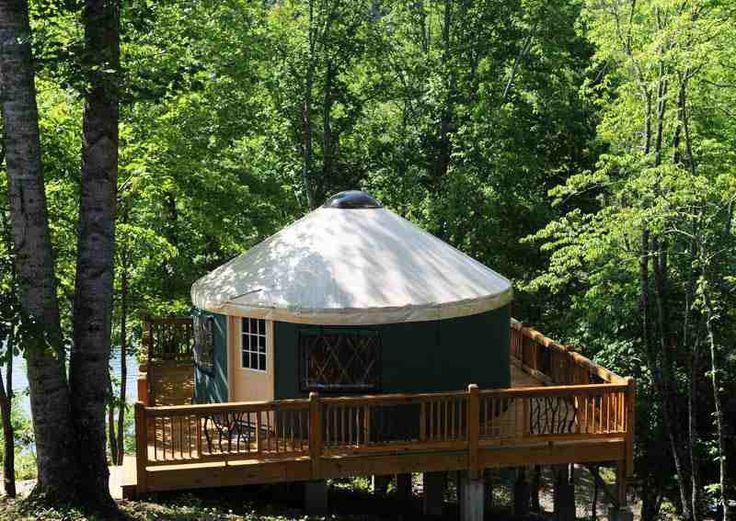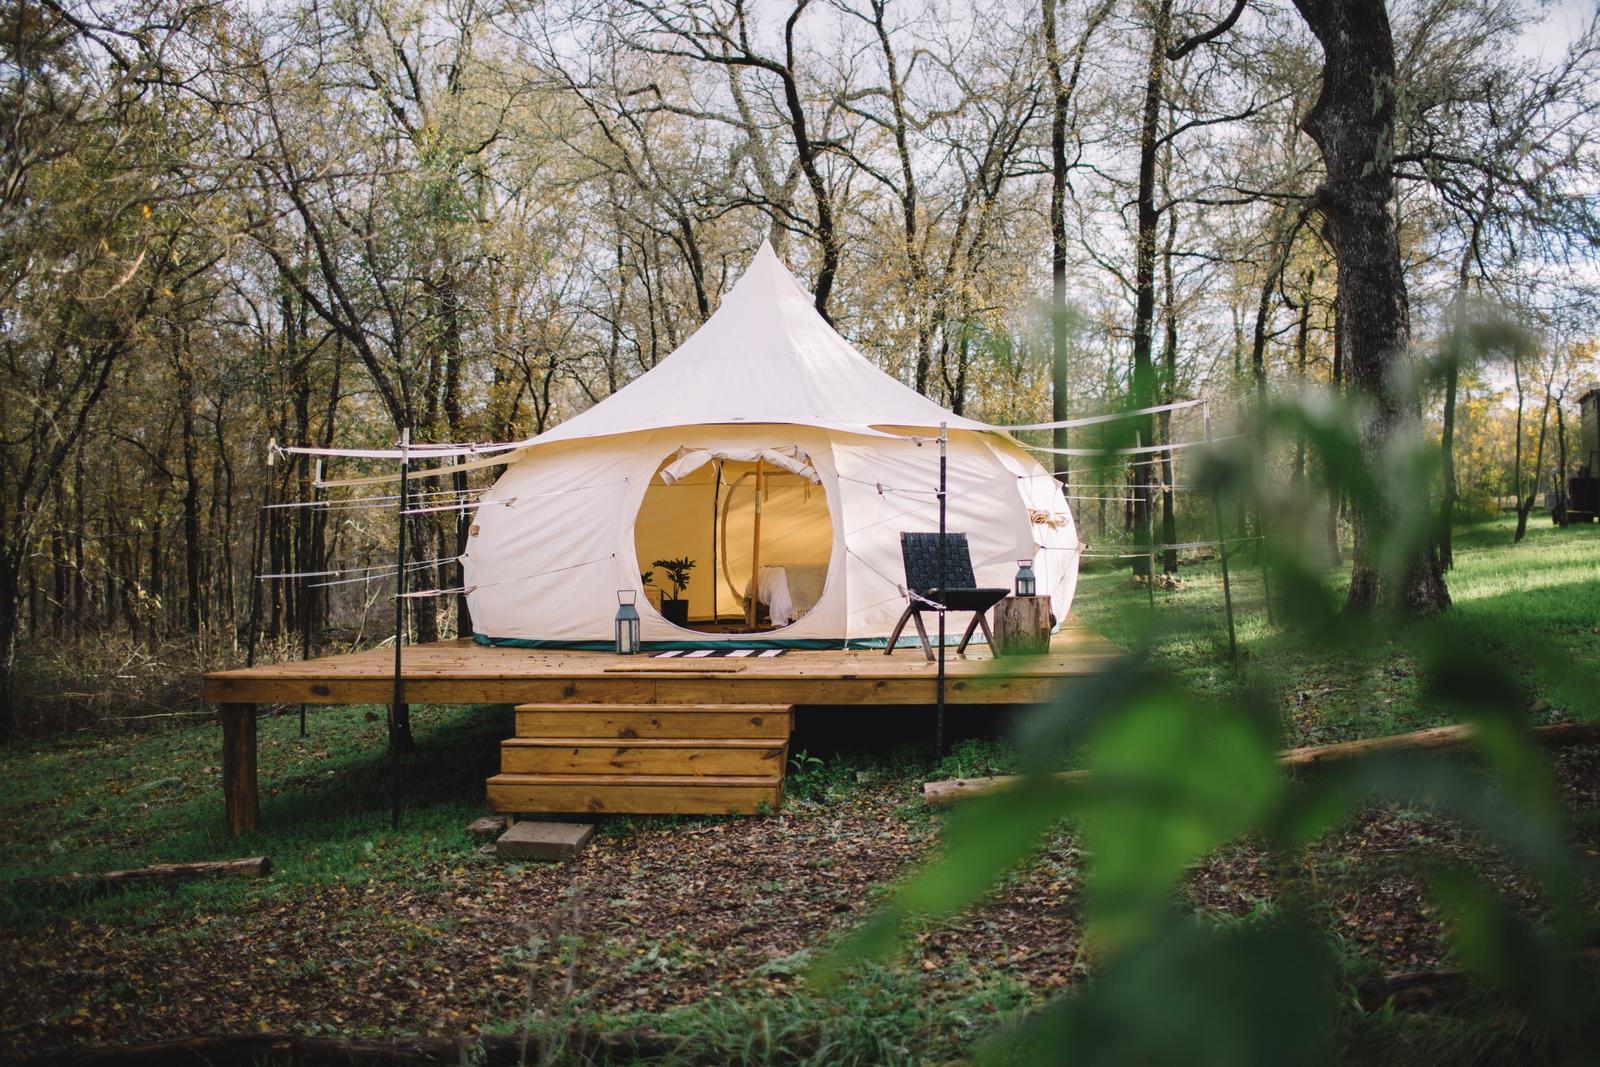The first image is the image on the left, the second image is the image on the right. For the images shown, is this caption "The left image contains a cottage surrounded by a wooden railing." true? Answer yes or no. Yes. The first image is the image on the left, the second image is the image on the right. Considering the images on both sides, is "An image shows a green yurt with a pale roof, and it is surrounded by a square railed deck." valid? Answer yes or no. Yes. The first image is the image on the left, the second image is the image on the right. For the images displayed, is the sentence "Multiple lawn chairs are on the ground in front of a round building with a cone-shaped roof." factually correct? Answer yes or no. No. 